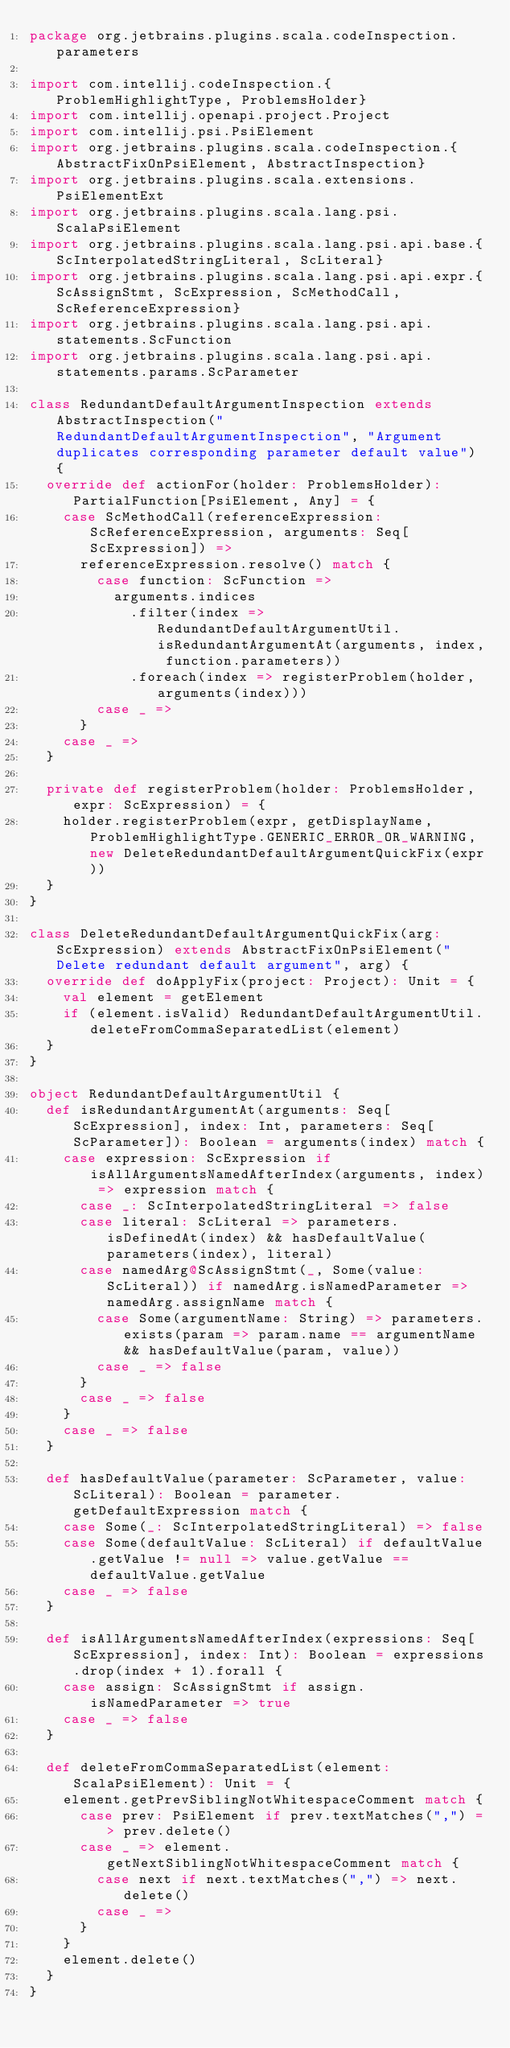<code> <loc_0><loc_0><loc_500><loc_500><_Scala_>package org.jetbrains.plugins.scala.codeInspection.parameters

import com.intellij.codeInspection.{ProblemHighlightType, ProblemsHolder}
import com.intellij.openapi.project.Project
import com.intellij.psi.PsiElement
import org.jetbrains.plugins.scala.codeInspection.{AbstractFixOnPsiElement, AbstractInspection}
import org.jetbrains.plugins.scala.extensions.PsiElementExt
import org.jetbrains.plugins.scala.lang.psi.ScalaPsiElement
import org.jetbrains.plugins.scala.lang.psi.api.base.{ScInterpolatedStringLiteral, ScLiteral}
import org.jetbrains.plugins.scala.lang.psi.api.expr.{ScAssignStmt, ScExpression, ScMethodCall, ScReferenceExpression}
import org.jetbrains.plugins.scala.lang.psi.api.statements.ScFunction
import org.jetbrains.plugins.scala.lang.psi.api.statements.params.ScParameter

class RedundantDefaultArgumentInspection extends AbstractInspection("RedundantDefaultArgumentInspection", "Argument duplicates corresponding parameter default value") {
  override def actionFor(holder: ProblemsHolder): PartialFunction[PsiElement, Any] = {
    case ScMethodCall(referenceExpression: ScReferenceExpression, arguments: Seq[ScExpression]) =>
      referenceExpression.resolve() match {
        case function: ScFunction =>
          arguments.indices
            .filter(index => RedundantDefaultArgumentUtil.isRedundantArgumentAt(arguments, index, function.parameters))
            .foreach(index => registerProblem(holder, arguments(index)))
        case _ =>
      }
    case _ =>
  }

  private def registerProblem(holder: ProblemsHolder, expr: ScExpression) = {
    holder.registerProblem(expr, getDisplayName, ProblemHighlightType.GENERIC_ERROR_OR_WARNING, new DeleteRedundantDefaultArgumentQuickFix(expr))
  }
}

class DeleteRedundantDefaultArgumentQuickFix(arg: ScExpression) extends AbstractFixOnPsiElement("Delete redundant default argument", arg) {
  override def doApplyFix(project: Project): Unit = {
    val element = getElement
    if (element.isValid) RedundantDefaultArgumentUtil.deleteFromCommaSeparatedList(element)
  }
}

object RedundantDefaultArgumentUtil {
  def isRedundantArgumentAt(arguments: Seq[ScExpression], index: Int, parameters: Seq[ScParameter]): Boolean = arguments(index) match {
    case expression: ScExpression if isAllArgumentsNamedAfterIndex(arguments, index) => expression match {
      case _: ScInterpolatedStringLiteral => false
      case literal: ScLiteral => parameters.isDefinedAt(index) && hasDefaultValue(parameters(index), literal)
      case namedArg@ScAssignStmt(_, Some(value: ScLiteral)) if namedArg.isNamedParameter => namedArg.assignName match {
        case Some(argumentName: String) => parameters.exists(param => param.name == argumentName && hasDefaultValue(param, value))
        case _ => false
      }
      case _ => false
    }
    case _ => false
  }

  def hasDefaultValue(parameter: ScParameter, value: ScLiteral): Boolean = parameter.getDefaultExpression match {
    case Some(_: ScInterpolatedStringLiteral) => false
    case Some(defaultValue: ScLiteral) if defaultValue.getValue != null => value.getValue == defaultValue.getValue
    case _ => false
  }

  def isAllArgumentsNamedAfterIndex(expressions: Seq[ScExpression], index: Int): Boolean = expressions.drop(index + 1).forall {
    case assign: ScAssignStmt if assign.isNamedParameter => true
    case _ => false
  }

  def deleteFromCommaSeparatedList(element: ScalaPsiElement): Unit = {
    element.getPrevSiblingNotWhitespaceComment match {
      case prev: PsiElement if prev.textMatches(",") => prev.delete()
      case _ => element.getNextSiblingNotWhitespaceComment match {
        case next if next.textMatches(",") => next.delete()
        case _ =>
      }
    }
    element.delete()
  }
}</code> 